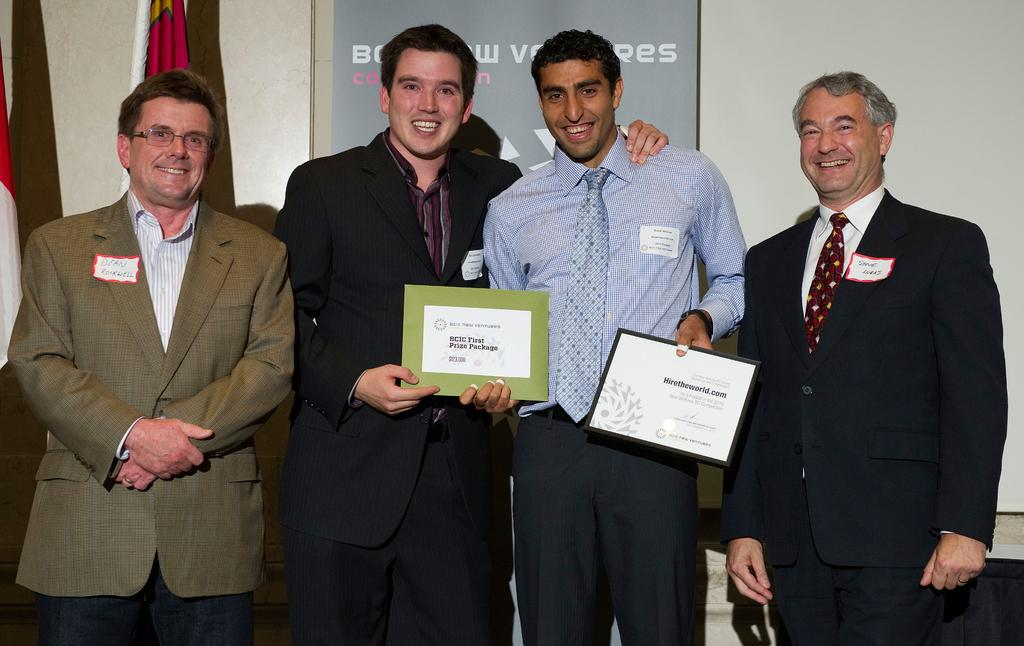How many people are in the image? There is a group of people in the image. What are two of the people holding? Two of the people are holding shields. What can be seen in the background of the image? There is a wall in the background of the image. What is on the wall in the image? There is a banner and a flag on the wall. Can you see any clouds in the image? There are no clouds visible in the image; it only shows a group of people, a wall, and objects on the wall. 